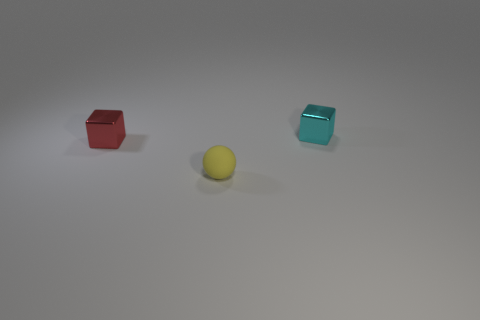Add 2 gray shiny spheres. How many objects exist? 5 Subtract all cyan cubes. How many cubes are left? 1 Add 1 cylinders. How many cylinders exist? 1 Subtract 0 purple cylinders. How many objects are left? 3 Subtract all spheres. How many objects are left? 2 Subtract all yellow cubes. Subtract all gray balls. How many cubes are left? 2 Subtract all shiny blocks. Subtract all small cyan objects. How many objects are left? 0 Add 1 red cubes. How many red cubes are left? 2 